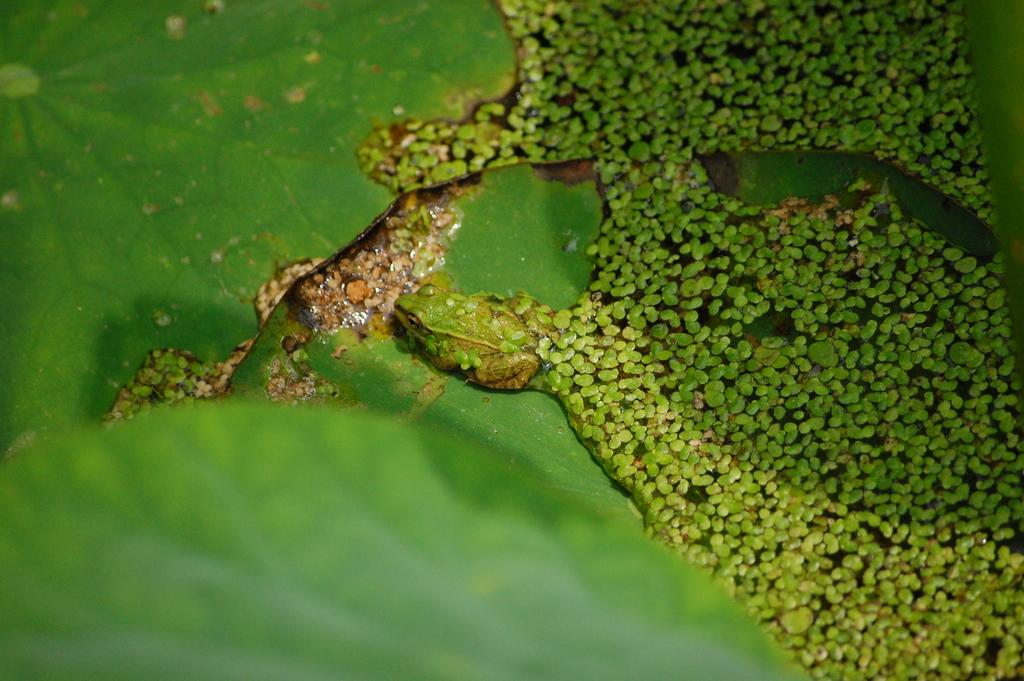What type of vegetation can be seen in the image? There are green leaves in the image. What animal is present on a leaf in the image? There is a frog on a leaf in the image. What is the surface of the water in the image? There are objects visible on the water in the image. What is the purpose of the quince in the image? There is no quince present in the image, so it is not possible to determine its purpose. 